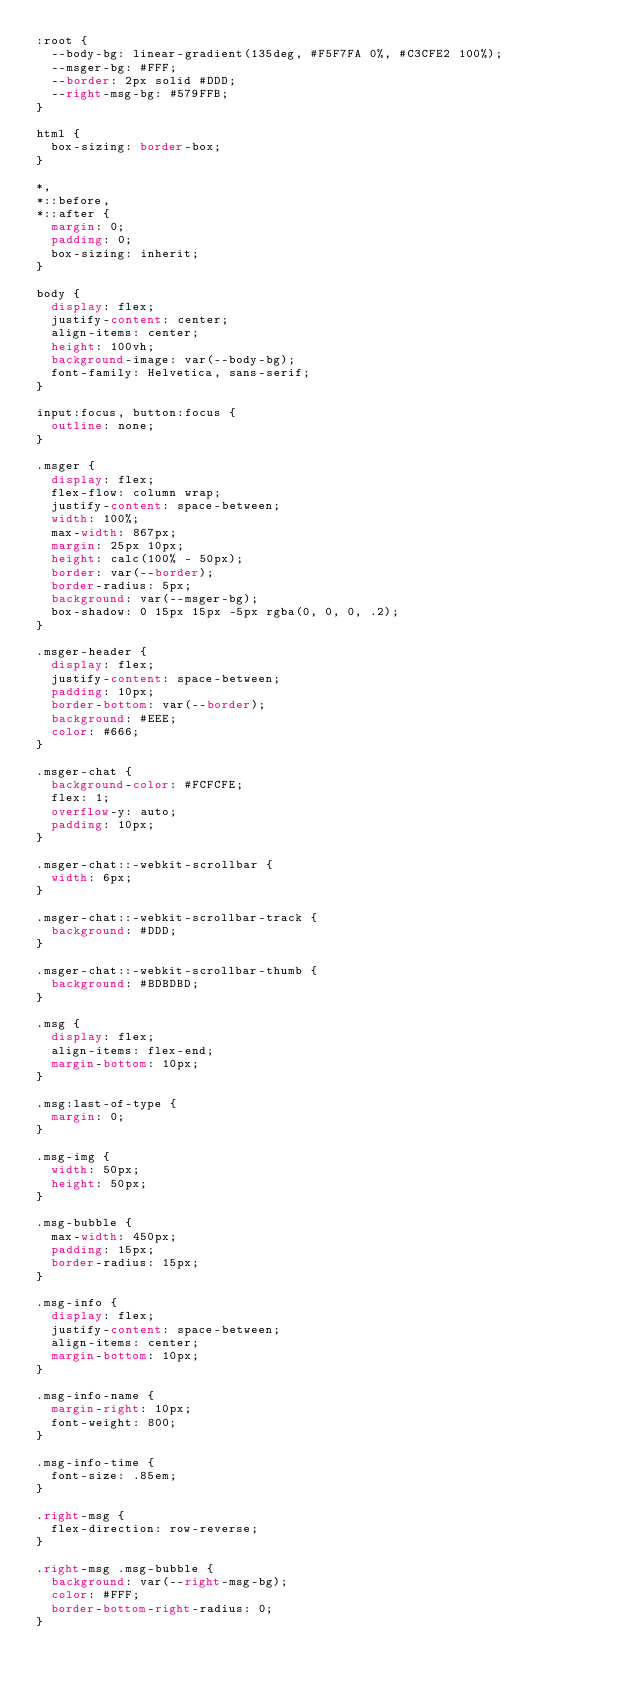<code> <loc_0><loc_0><loc_500><loc_500><_CSS_>:root {
  --body-bg: linear-gradient(135deg, #F5F7FA 0%, #C3CFE2 100%);
  --msger-bg: #FFF;
  --border: 2px solid #DDD;
  --right-msg-bg: #579FFB;
}

html {
  box-sizing: border-box;
}

*,
*::before,
*::after {
  margin: 0;
  padding: 0;
  box-sizing: inherit;
}

body {
  display: flex;
  justify-content: center;
  align-items: center;
  height: 100vh;
  background-image: var(--body-bg);
  font-family: Helvetica, sans-serif;
}

input:focus, button:focus {
  outline: none;
}

.msger {
  display: flex;
  flex-flow: column wrap;
  justify-content: space-between;
  width: 100%;
  max-width: 867px;
  margin: 25px 10px;
  height: calc(100% - 50px);
  border: var(--border);
  border-radius: 5px;
  background: var(--msger-bg);
  box-shadow: 0 15px 15px -5px rgba(0, 0, 0, .2);
}

.msger-header {
  display: flex;
  justify-content: space-between;
  padding: 10px;
  border-bottom: var(--border);
  background: #EEE;
  color: #666;
}

.msger-chat {
  background-color: #FCFCFE;
  flex: 1;
  overflow-y: auto;
  padding: 10px;
}

.msger-chat::-webkit-scrollbar {
  width: 6px;
}

.msger-chat::-webkit-scrollbar-track {
  background: #DDD;
}

.msger-chat::-webkit-scrollbar-thumb {
  background: #BDBDBD;
}

.msg {
  display: flex;
  align-items: flex-end;
  margin-bottom: 10px;
}

.msg:last-of-type {
  margin: 0;
}

.msg-img {
  width: 50px;
  height: 50px;
}

.msg-bubble {
  max-width: 450px;
  padding: 15px;
  border-radius: 15px;
}

.msg-info {
  display: flex;
  justify-content: space-between;
  align-items: center;
  margin-bottom: 10px;
}

.msg-info-name {
  margin-right: 10px;
  font-weight: 800;
}

.msg-info-time {
  font-size: .85em;
}

.right-msg {
  flex-direction: row-reverse;
}

.right-msg .msg-bubble {
  background: var(--right-msg-bg);
  color: #FFF;
  border-bottom-right-radius: 0;
}
</code> 